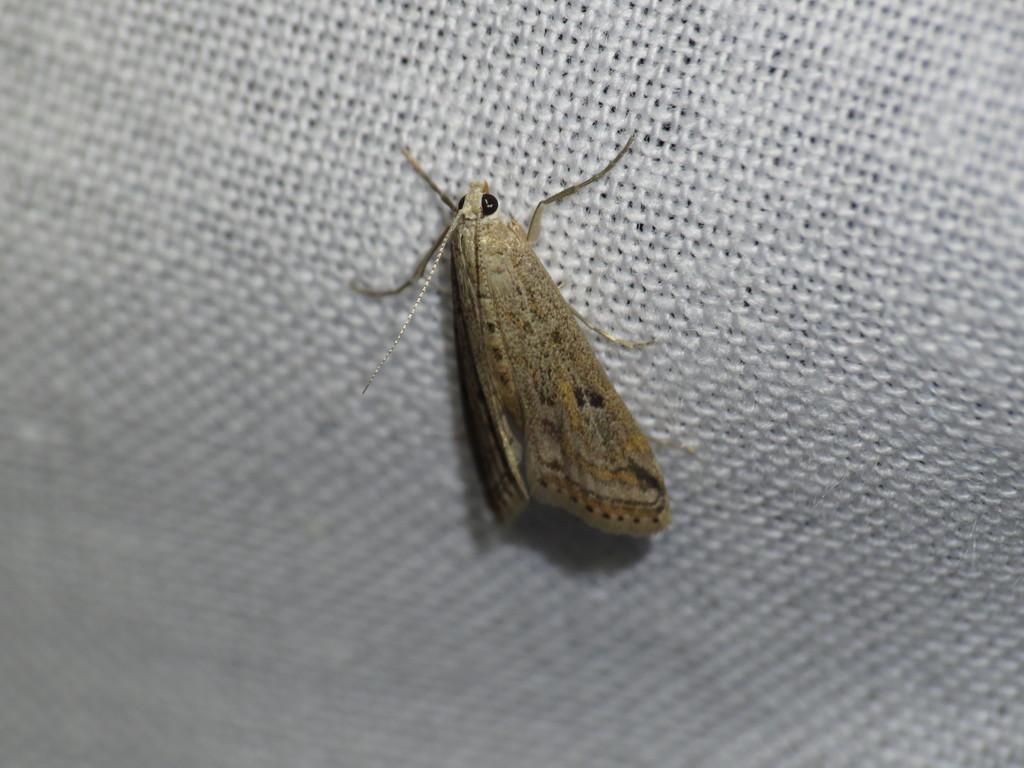Please provide a concise description of this image. In this picture, we see an insect. In the background, it is white in color and it might be a net. 